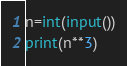Convert code to text. <code><loc_0><loc_0><loc_500><loc_500><_Python_>n=int(input())
print(n**3)</code> 